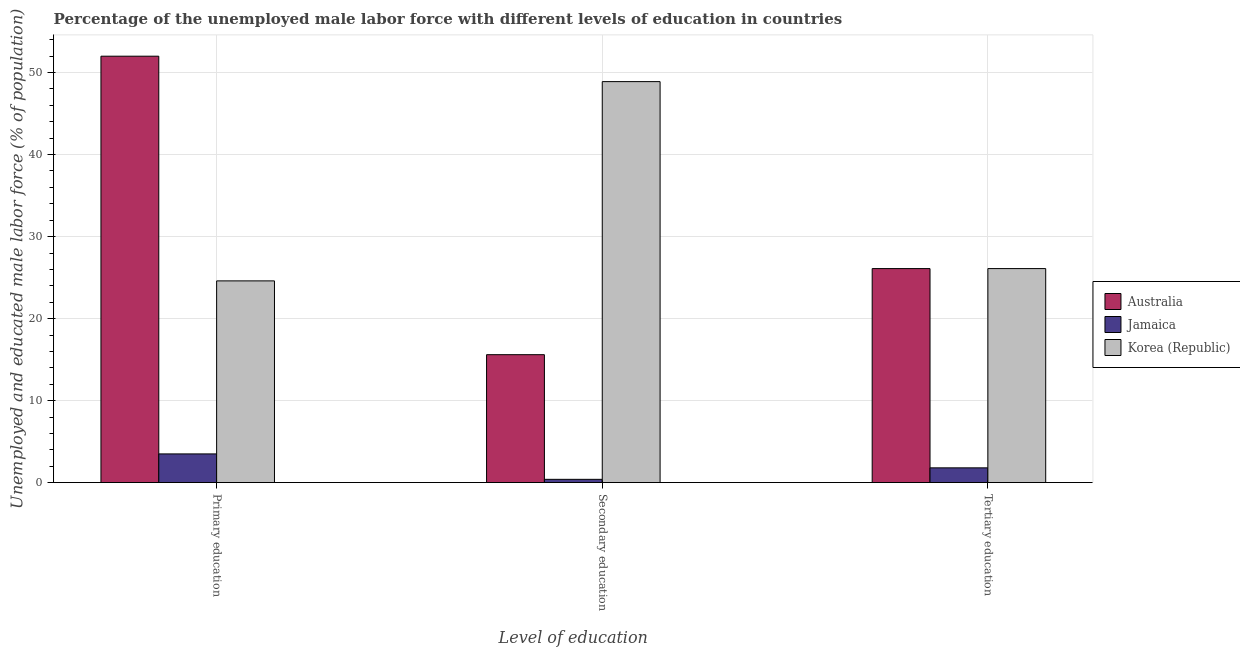How many different coloured bars are there?
Provide a short and direct response. 3. How many groups of bars are there?
Your answer should be compact. 3. Are the number of bars per tick equal to the number of legend labels?
Make the answer very short. Yes. Are the number of bars on each tick of the X-axis equal?
Your answer should be very brief. Yes. How many bars are there on the 3rd tick from the right?
Make the answer very short. 3. What is the label of the 3rd group of bars from the left?
Provide a short and direct response. Tertiary education. What is the percentage of male labor force who received tertiary education in Jamaica?
Your answer should be compact. 1.8. Across all countries, what is the maximum percentage of male labor force who received secondary education?
Your answer should be compact. 48.9. In which country was the percentage of male labor force who received secondary education minimum?
Your answer should be very brief. Jamaica. What is the total percentage of male labor force who received tertiary education in the graph?
Provide a short and direct response. 54. What is the difference between the percentage of male labor force who received primary education in Jamaica and that in Korea (Republic)?
Keep it short and to the point. -21.1. What is the difference between the percentage of male labor force who received secondary education in Australia and the percentage of male labor force who received primary education in Jamaica?
Keep it short and to the point. 12.1. What is the average percentage of male labor force who received tertiary education per country?
Provide a succinct answer. 18. What is the difference between the percentage of male labor force who received secondary education and percentage of male labor force who received tertiary education in Australia?
Your answer should be compact. -10.5. What is the ratio of the percentage of male labor force who received primary education in Jamaica to that in Australia?
Your answer should be very brief. 0.07. Is the percentage of male labor force who received tertiary education in Korea (Republic) less than that in Australia?
Offer a terse response. No. What is the difference between the highest and the lowest percentage of male labor force who received primary education?
Give a very brief answer. 48.5. What does the 3rd bar from the left in Secondary education represents?
Offer a terse response. Korea (Republic). What does the 2nd bar from the right in Secondary education represents?
Offer a very short reply. Jamaica. Is it the case that in every country, the sum of the percentage of male labor force who received primary education and percentage of male labor force who received secondary education is greater than the percentage of male labor force who received tertiary education?
Offer a terse response. Yes. Are all the bars in the graph horizontal?
Provide a succinct answer. No. How many countries are there in the graph?
Give a very brief answer. 3. What is the difference between two consecutive major ticks on the Y-axis?
Your response must be concise. 10. Does the graph contain any zero values?
Your response must be concise. No. Does the graph contain grids?
Offer a terse response. Yes. How many legend labels are there?
Offer a terse response. 3. How are the legend labels stacked?
Make the answer very short. Vertical. What is the title of the graph?
Make the answer very short. Percentage of the unemployed male labor force with different levels of education in countries. What is the label or title of the X-axis?
Your answer should be very brief. Level of education. What is the label or title of the Y-axis?
Provide a succinct answer. Unemployed and educated male labor force (% of population). What is the Unemployed and educated male labor force (% of population) of Jamaica in Primary education?
Ensure brevity in your answer.  3.5. What is the Unemployed and educated male labor force (% of population) of Korea (Republic) in Primary education?
Make the answer very short. 24.6. What is the Unemployed and educated male labor force (% of population) of Australia in Secondary education?
Make the answer very short. 15.6. What is the Unemployed and educated male labor force (% of population) in Jamaica in Secondary education?
Give a very brief answer. 0.4. What is the Unemployed and educated male labor force (% of population) of Korea (Republic) in Secondary education?
Provide a short and direct response. 48.9. What is the Unemployed and educated male labor force (% of population) of Australia in Tertiary education?
Make the answer very short. 26.1. What is the Unemployed and educated male labor force (% of population) in Jamaica in Tertiary education?
Provide a short and direct response. 1.8. What is the Unemployed and educated male labor force (% of population) of Korea (Republic) in Tertiary education?
Ensure brevity in your answer.  26.1. Across all Level of education, what is the maximum Unemployed and educated male labor force (% of population) of Australia?
Offer a very short reply. 52. Across all Level of education, what is the maximum Unemployed and educated male labor force (% of population) of Jamaica?
Give a very brief answer. 3.5. Across all Level of education, what is the maximum Unemployed and educated male labor force (% of population) in Korea (Republic)?
Ensure brevity in your answer.  48.9. Across all Level of education, what is the minimum Unemployed and educated male labor force (% of population) in Australia?
Your response must be concise. 15.6. Across all Level of education, what is the minimum Unemployed and educated male labor force (% of population) in Jamaica?
Offer a very short reply. 0.4. Across all Level of education, what is the minimum Unemployed and educated male labor force (% of population) of Korea (Republic)?
Make the answer very short. 24.6. What is the total Unemployed and educated male labor force (% of population) of Australia in the graph?
Your answer should be very brief. 93.7. What is the total Unemployed and educated male labor force (% of population) of Korea (Republic) in the graph?
Ensure brevity in your answer.  99.6. What is the difference between the Unemployed and educated male labor force (% of population) in Australia in Primary education and that in Secondary education?
Offer a terse response. 36.4. What is the difference between the Unemployed and educated male labor force (% of population) of Korea (Republic) in Primary education and that in Secondary education?
Your answer should be compact. -24.3. What is the difference between the Unemployed and educated male labor force (% of population) of Australia in Primary education and that in Tertiary education?
Offer a very short reply. 25.9. What is the difference between the Unemployed and educated male labor force (% of population) of Korea (Republic) in Primary education and that in Tertiary education?
Your answer should be compact. -1.5. What is the difference between the Unemployed and educated male labor force (% of population) of Australia in Secondary education and that in Tertiary education?
Give a very brief answer. -10.5. What is the difference between the Unemployed and educated male labor force (% of population) of Korea (Republic) in Secondary education and that in Tertiary education?
Offer a terse response. 22.8. What is the difference between the Unemployed and educated male labor force (% of population) of Australia in Primary education and the Unemployed and educated male labor force (% of population) of Jamaica in Secondary education?
Provide a succinct answer. 51.6. What is the difference between the Unemployed and educated male labor force (% of population) in Jamaica in Primary education and the Unemployed and educated male labor force (% of population) in Korea (Republic) in Secondary education?
Provide a succinct answer. -45.4. What is the difference between the Unemployed and educated male labor force (% of population) in Australia in Primary education and the Unemployed and educated male labor force (% of population) in Jamaica in Tertiary education?
Offer a terse response. 50.2. What is the difference between the Unemployed and educated male labor force (% of population) in Australia in Primary education and the Unemployed and educated male labor force (% of population) in Korea (Republic) in Tertiary education?
Give a very brief answer. 25.9. What is the difference between the Unemployed and educated male labor force (% of population) of Jamaica in Primary education and the Unemployed and educated male labor force (% of population) of Korea (Republic) in Tertiary education?
Your answer should be very brief. -22.6. What is the difference between the Unemployed and educated male labor force (% of population) in Australia in Secondary education and the Unemployed and educated male labor force (% of population) in Korea (Republic) in Tertiary education?
Offer a very short reply. -10.5. What is the difference between the Unemployed and educated male labor force (% of population) of Jamaica in Secondary education and the Unemployed and educated male labor force (% of population) of Korea (Republic) in Tertiary education?
Offer a very short reply. -25.7. What is the average Unemployed and educated male labor force (% of population) of Australia per Level of education?
Offer a terse response. 31.23. What is the average Unemployed and educated male labor force (% of population) of Jamaica per Level of education?
Offer a very short reply. 1.9. What is the average Unemployed and educated male labor force (% of population) in Korea (Republic) per Level of education?
Your response must be concise. 33.2. What is the difference between the Unemployed and educated male labor force (% of population) in Australia and Unemployed and educated male labor force (% of population) in Jamaica in Primary education?
Your answer should be compact. 48.5. What is the difference between the Unemployed and educated male labor force (% of population) in Australia and Unemployed and educated male labor force (% of population) in Korea (Republic) in Primary education?
Keep it short and to the point. 27.4. What is the difference between the Unemployed and educated male labor force (% of population) in Jamaica and Unemployed and educated male labor force (% of population) in Korea (Republic) in Primary education?
Keep it short and to the point. -21.1. What is the difference between the Unemployed and educated male labor force (% of population) of Australia and Unemployed and educated male labor force (% of population) of Korea (Republic) in Secondary education?
Provide a short and direct response. -33.3. What is the difference between the Unemployed and educated male labor force (% of population) of Jamaica and Unemployed and educated male labor force (% of population) of Korea (Republic) in Secondary education?
Ensure brevity in your answer.  -48.5. What is the difference between the Unemployed and educated male labor force (% of population) in Australia and Unemployed and educated male labor force (% of population) in Jamaica in Tertiary education?
Provide a short and direct response. 24.3. What is the difference between the Unemployed and educated male labor force (% of population) in Australia and Unemployed and educated male labor force (% of population) in Korea (Republic) in Tertiary education?
Offer a very short reply. 0. What is the difference between the Unemployed and educated male labor force (% of population) in Jamaica and Unemployed and educated male labor force (% of population) in Korea (Republic) in Tertiary education?
Make the answer very short. -24.3. What is the ratio of the Unemployed and educated male labor force (% of population) in Jamaica in Primary education to that in Secondary education?
Keep it short and to the point. 8.75. What is the ratio of the Unemployed and educated male labor force (% of population) in Korea (Republic) in Primary education to that in Secondary education?
Your answer should be compact. 0.5. What is the ratio of the Unemployed and educated male labor force (% of population) in Australia in Primary education to that in Tertiary education?
Offer a terse response. 1.99. What is the ratio of the Unemployed and educated male labor force (% of population) of Jamaica in Primary education to that in Tertiary education?
Offer a terse response. 1.94. What is the ratio of the Unemployed and educated male labor force (% of population) in Korea (Republic) in Primary education to that in Tertiary education?
Your answer should be very brief. 0.94. What is the ratio of the Unemployed and educated male labor force (% of population) in Australia in Secondary education to that in Tertiary education?
Offer a very short reply. 0.6. What is the ratio of the Unemployed and educated male labor force (% of population) in Jamaica in Secondary education to that in Tertiary education?
Give a very brief answer. 0.22. What is the ratio of the Unemployed and educated male labor force (% of population) in Korea (Republic) in Secondary education to that in Tertiary education?
Make the answer very short. 1.87. What is the difference between the highest and the second highest Unemployed and educated male labor force (% of population) of Australia?
Keep it short and to the point. 25.9. What is the difference between the highest and the second highest Unemployed and educated male labor force (% of population) of Jamaica?
Keep it short and to the point. 1.7. What is the difference between the highest and the second highest Unemployed and educated male labor force (% of population) in Korea (Republic)?
Ensure brevity in your answer.  22.8. What is the difference between the highest and the lowest Unemployed and educated male labor force (% of population) of Australia?
Keep it short and to the point. 36.4. What is the difference between the highest and the lowest Unemployed and educated male labor force (% of population) in Jamaica?
Your answer should be compact. 3.1. What is the difference between the highest and the lowest Unemployed and educated male labor force (% of population) of Korea (Republic)?
Your response must be concise. 24.3. 